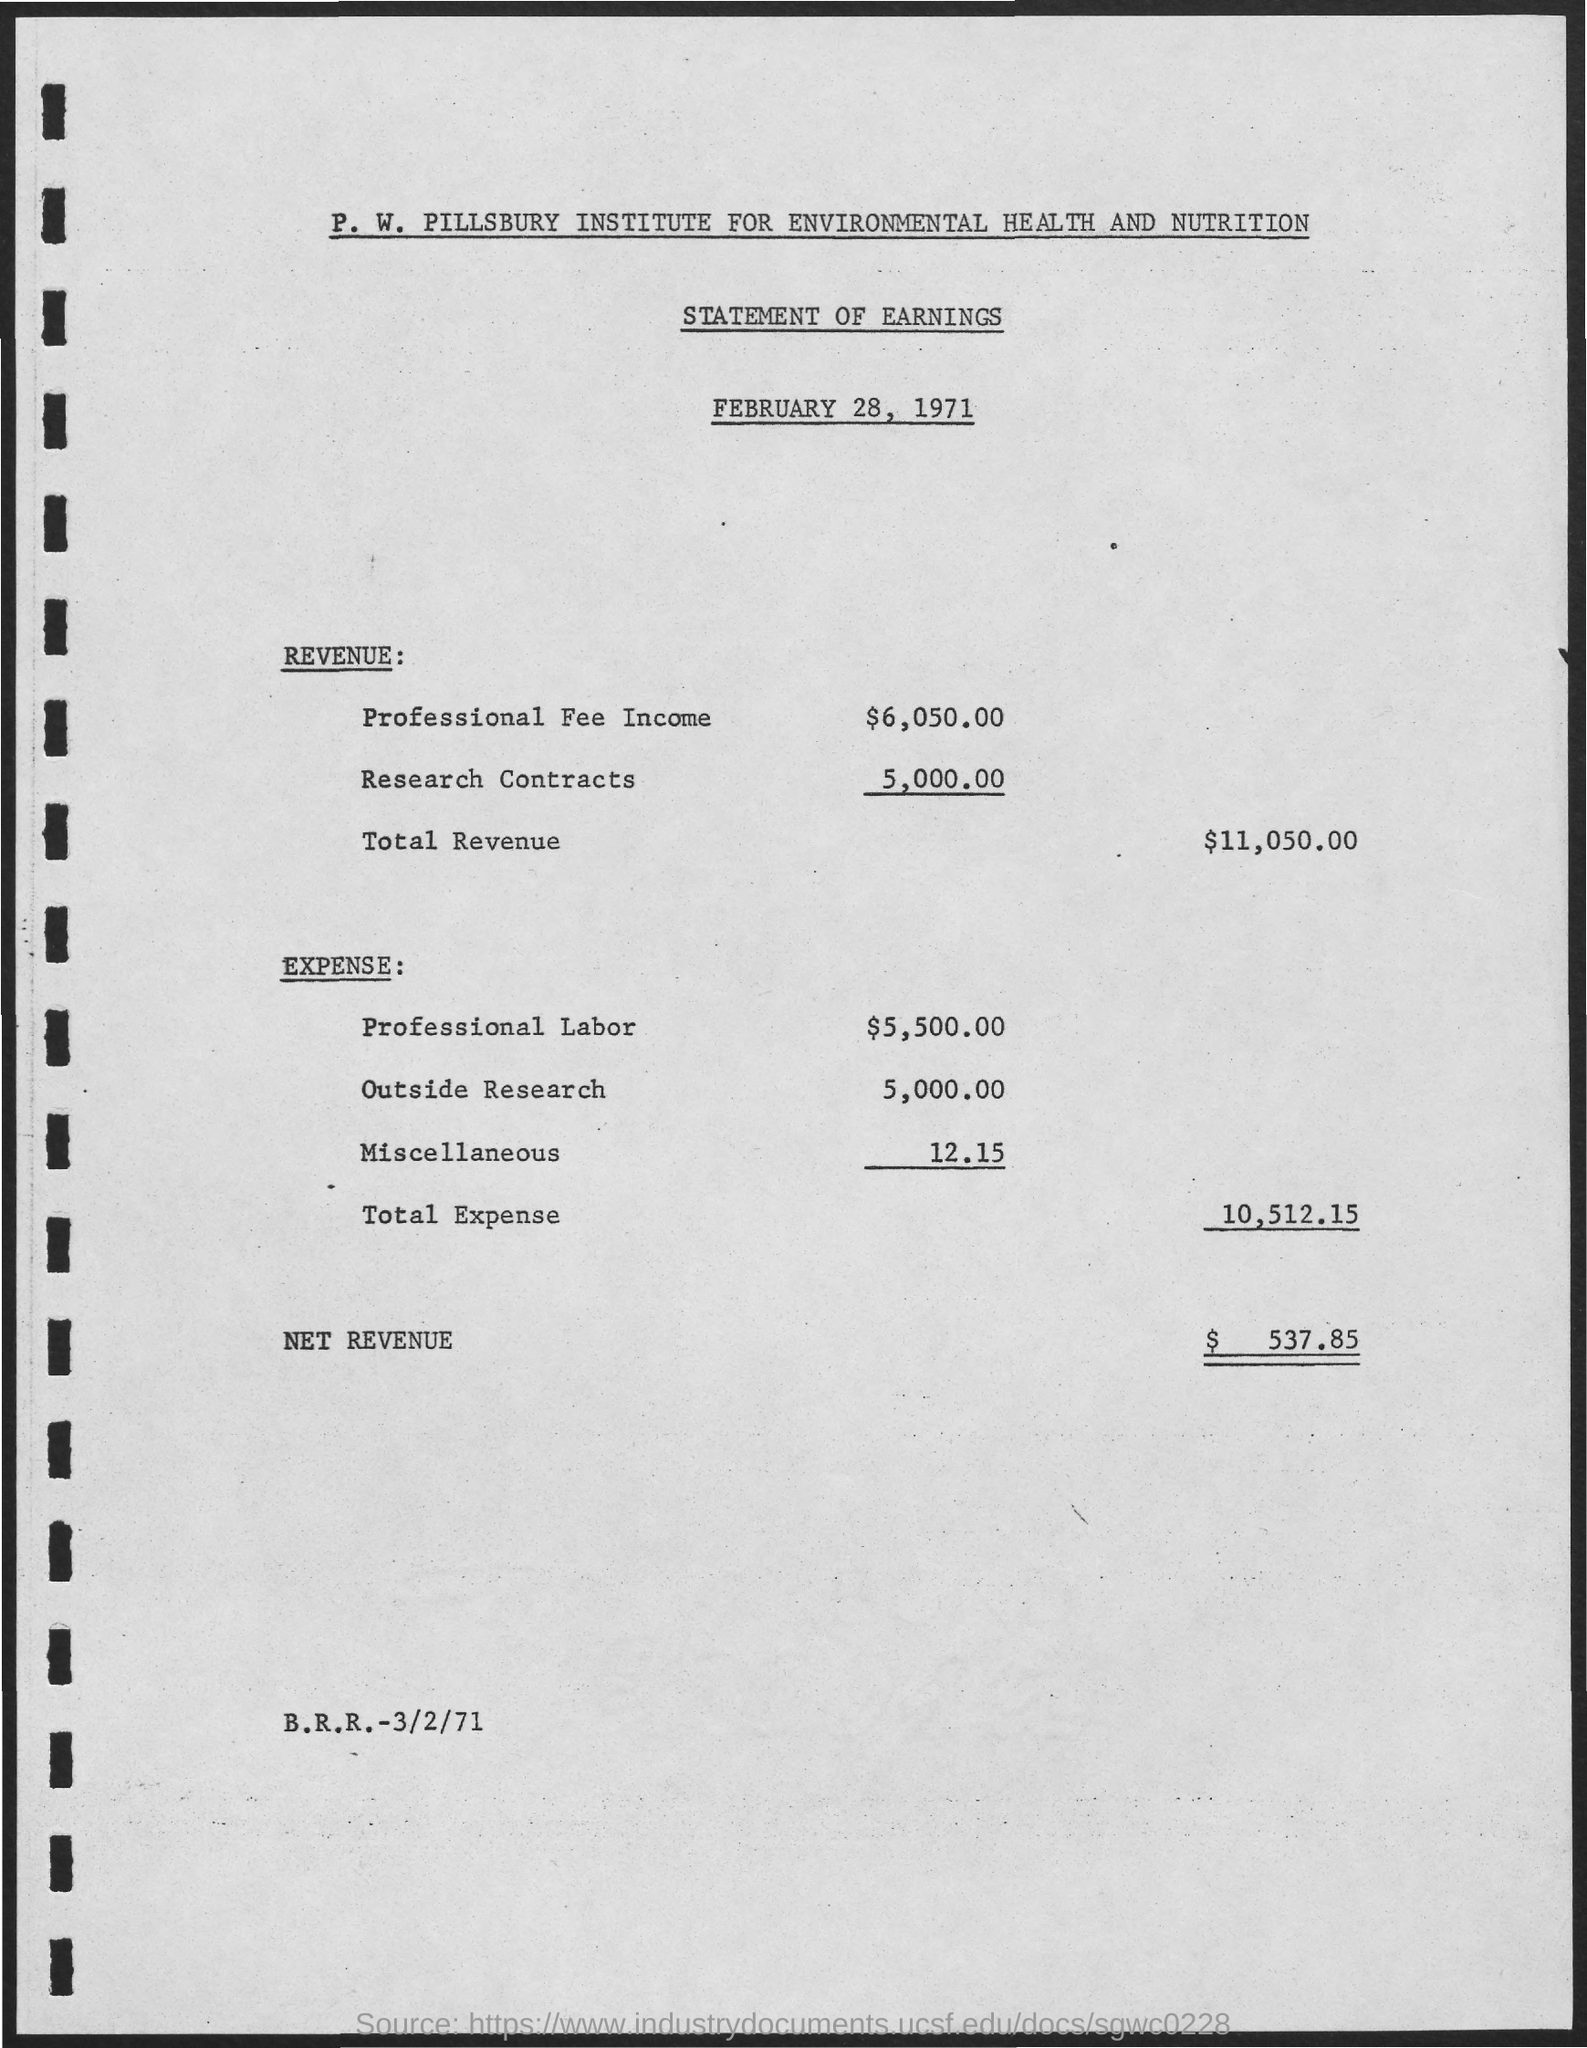What type of statement is given here?
Keep it short and to the point. STATEMENT OF EARNINGS. What is the issued date of the statement?
Provide a succinct answer. February 28, 1971. What is the Revenue earned from Professional Fee income?
Provide a succinct answer. $6,050.00. What is the total revenue as per the statement?
Keep it short and to the point. $11,050.00. What is the expense for professional labor as per the statement?
Offer a terse response. $5,500.00. What is the net revenue mentioned in the statement?
Ensure brevity in your answer.  $ 537.85. 